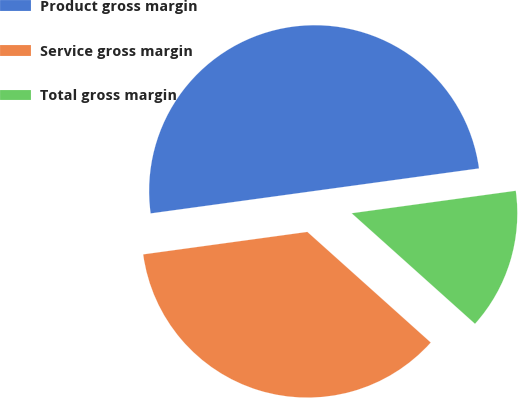Convert chart. <chart><loc_0><loc_0><loc_500><loc_500><pie_chart><fcel>Product gross margin<fcel>Service gross margin<fcel>Total gross margin<nl><fcel>50.0%<fcel>36.2%<fcel>13.8%<nl></chart> 